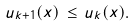Convert formula to latex. <formula><loc_0><loc_0><loc_500><loc_500>u _ { k + 1 } ( x ) \, \leq \, u _ { k } ( x ) .</formula> 